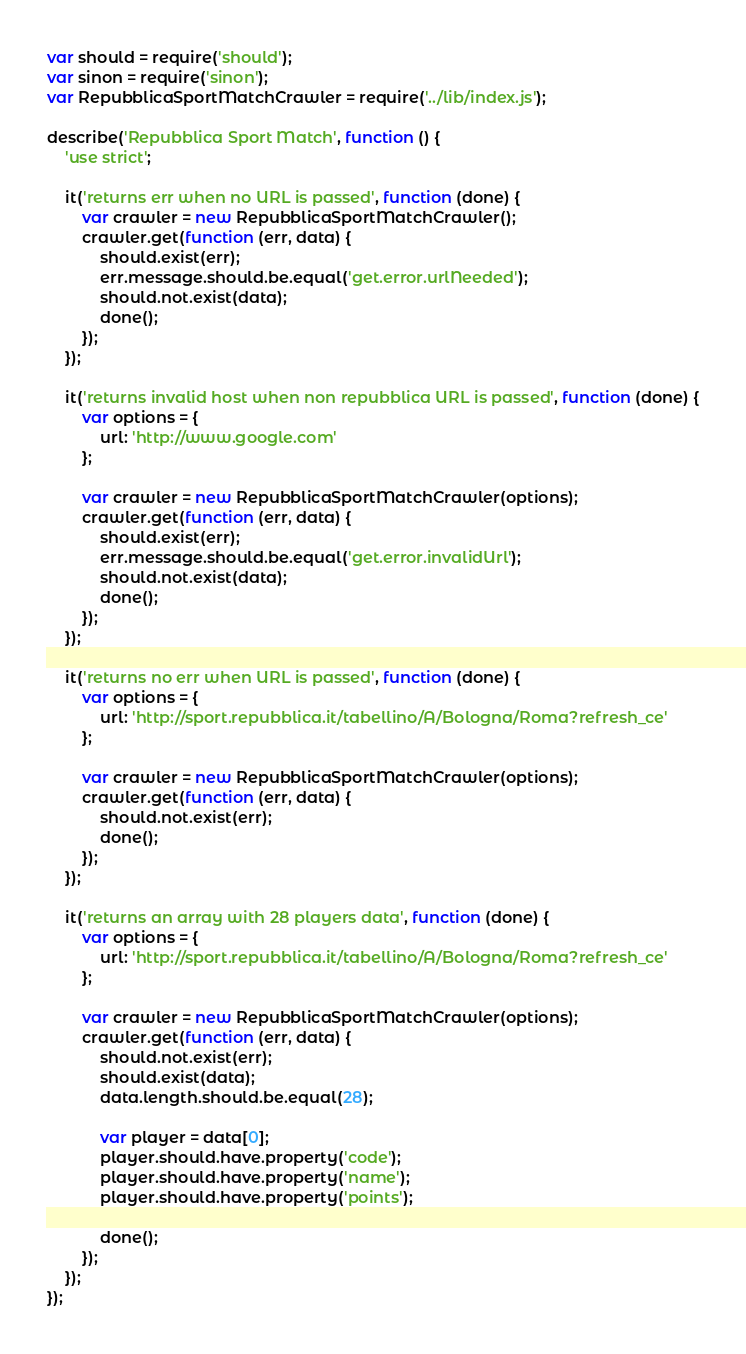Convert code to text. <code><loc_0><loc_0><loc_500><loc_500><_JavaScript_>var should = require('should');
var sinon = require('sinon');
var RepubblicaSportMatchCrawler = require('../lib/index.js');

describe('Repubblica Sport Match', function () {
    'use strict';

    it('returns err when no URL is passed', function (done) {
        var crawler = new RepubblicaSportMatchCrawler();
        crawler.get(function (err, data) {
            should.exist(err);
            err.message.should.be.equal('get.error.urlNeeded');
            should.not.exist(data);
            done();
        });
    });

    it('returns invalid host when non repubblica URL is passed', function (done) {
        var options = {
            url: 'http://www.google.com'
        };

        var crawler = new RepubblicaSportMatchCrawler(options);
        crawler.get(function (err, data) {
            should.exist(err);
            err.message.should.be.equal('get.error.invalidUrl');
            should.not.exist(data);
            done();
        });
    });

    it('returns no err when URL is passed', function (done) {
        var options = {
            url: 'http://sport.repubblica.it/tabellino/A/Bologna/Roma?refresh_ce'
        };

        var crawler = new RepubblicaSportMatchCrawler(options);
        crawler.get(function (err, data) {
            should.not.exist(err);
            done();
        });
    });

    it('returns an array with 28 players data', function (done) {
        var options = {
            url: 'http://sport.repubblica.it/tabellino/A/Bologna/Roma?refresh_ce'
        };

        var crawler = new RepubblicaSportMatchCrawler(options);
        crawler.get(function (err, data) {
            should.not.exist(err);
            should.exist(data);
            data.length.should.be.equal(28);

            var player = data[0];
            player.should.have.property('code');
            player.should.have.property('name');
            player.should.have.property('points');

            done();
        });
    });
});</code> 